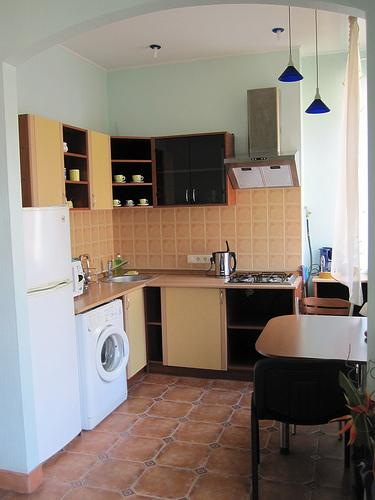Summarize the aspects of the image focusing on the general subject and key details. Kitchen scene with multiple appliances, a wooden table, and decorative accents like teacups and blue lights. Mention some key objects found in the image along with their colors. White refrigerator and dishwasher, black and silver coffee maker, wooden dining table, and blue lights. Write a short statement focusing on the primary object and surroundings present in this image. A white refrigerator and other kitchen appliances are surrounded by cabinets, shelves, a dining table, and hanging blue lights. Mention the most notable features of the image in a concise sentence. Kitchen scene with white appliances, wooden table, teacups on shelves, and blue hanging lights. Explain the main theme of the image in a sentence, focusing on the types of objects present. A fully-equipped kitchen with various appliances, a dining table, and decorative elements like lights and teacups. What are the various kitchen appliances present in the scene? Refrigerator, dishwasher, microwave, coffee maker, gas stove, vents, sink and washing machine are present. Describe the image by emphasizing the color scheme. White appliances, blue lights, and yellow teacups adorn a kitchen with wooden accents and shelves. Write a brief statement about the furnishings and objects observed in the image. Kitchen features white appliances, wooden table and shelves, a variety of teacups, and blue hanging lights. Provide a brief description of the kitchen image focusing on the position of main objects. Kitchen with refrigerator at left, gas stove at right, dining table in center, and hanging lights above. Briefly explain the image's layout with a focus on the colors and objects. A colorful kitchen with white appliances, a wooden table, blue and white lights, and yellow teacups on brown shelves. 